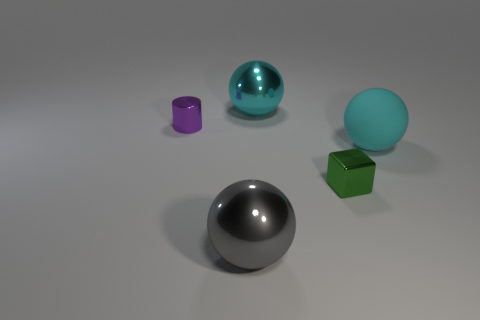There is a big metal object that is on the left side of the large shiny object behind the big gray metal ball; what is its color?
Ensure brevity in your answer.  Gray. There is a big ball that is in front of the green thing; is it the same color as the shiny block?
Provide a short and direct response. No. What shape is the cyan object in front of the cyan ball that is behind the object on the right side of the small green metallic block?
Provide a succinct answer. Sphere. What number of small metallic cylinders are on the right side of the large ball in front of the big cyan matte object?
Make the answer very short. 0. Are the cylinder and the large gray thing made of the same material?
Keep it short and to the point. Yes. How many green blocks are behind the large metallic sphere that is in front of the big metallic sphere that is behind the big gray object?
Your response must be concise. 1. What is the color of the large shiny ball that is in front of the tiny green object?
Make the answer very short. Gray. There is a tiny thing behind the big thing right of the cyan metallic ball; what is its shape?
Offer a very short reply. Cylinder. Is the metallic cube the same color as the small shiny cylinder?
Make the answer very short. No. How many spheres are either large gray things or shiny objects?
Offer a very short reply. 2. 